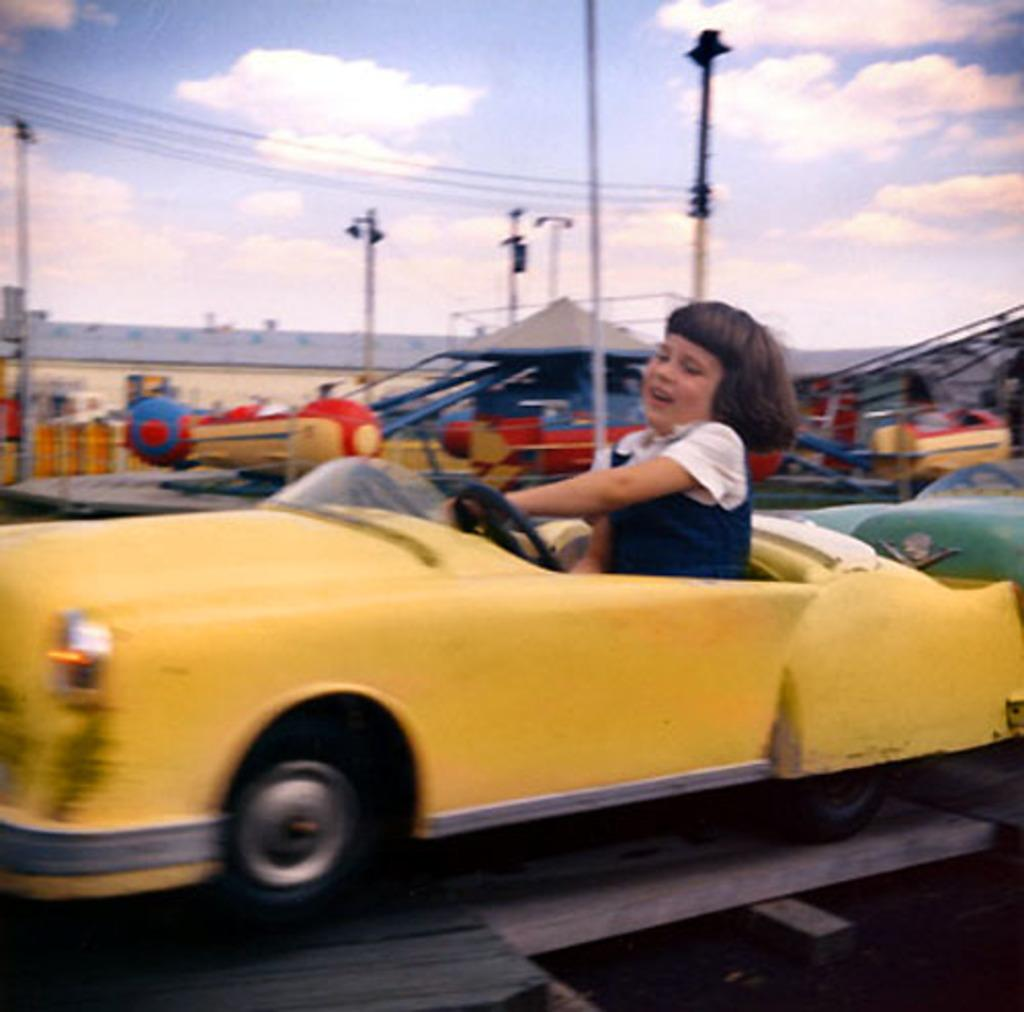What is the girl doing in the image? The girl is seated in a toy car in the image. What type of location does the image appear to depict? The setting appears to be a fun zone. What structure can be seen in the image? There is a building visible in the image. What are the poles used for in the image? The purpose of the poles in the image is not specified, but they could be used for various purposes such as lighting or decoration. How would you describe the weather based on the sky in the image? The sky is blue and cloudy in the image, suggesting a partly cloudy day. What type of linen is draped over the toy car in the image? There is no linen draped over the toy car in the image. How many bulbs are visible on the poles in the image? There are no bulbs visible on the poles in the image. 